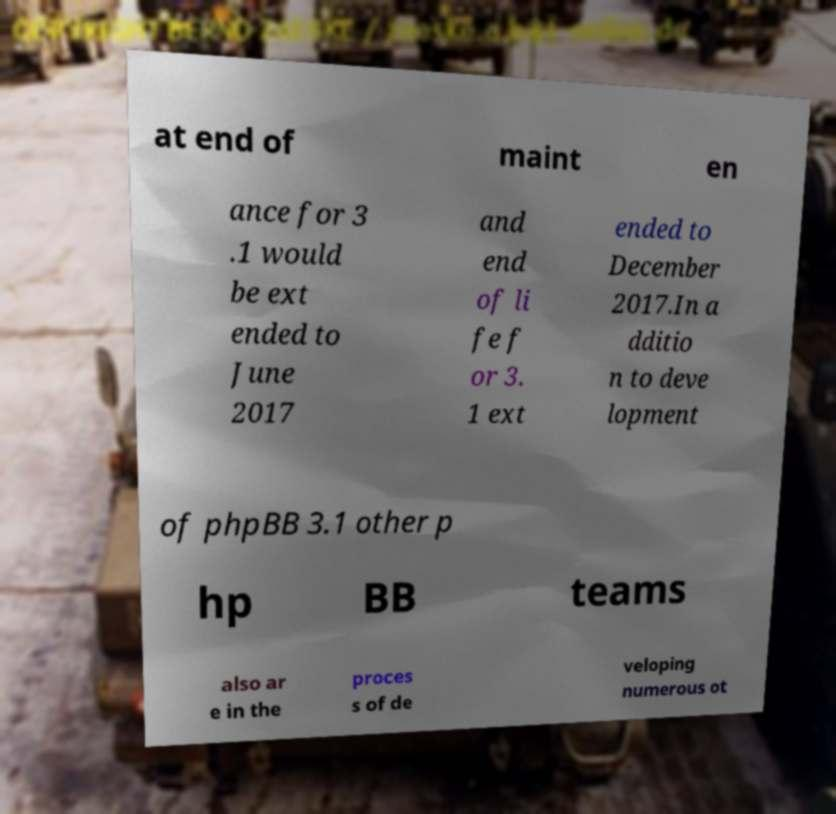Please identify and transcribe the text found in this image. at end of maint en ance for 3 .1 would be ext ended to June 2017 and end of li fe f or 3. 1 ext ended to December 2017.In a dditio n to deve lopment of phpBB 3.1 other p hp BB teams also ar e in the proces s of de veloping numerous ot 